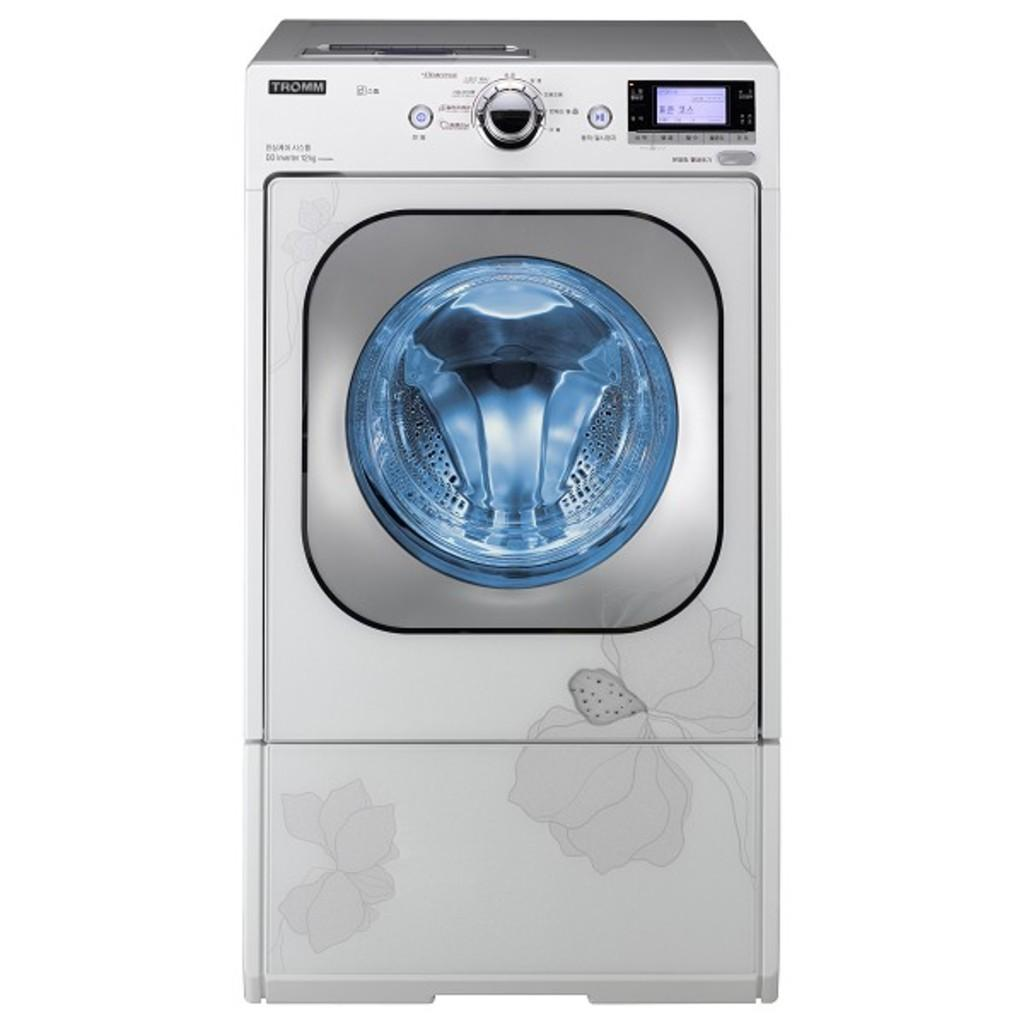What appliance is the main subject of the image? There is a washing machine in the image. Where is the washing machine located in the image? The washing machine is in the center of the image. What word is written on the dress in the image? There is no dress present in the image; it features a washing machine. On what type of surface is the washing machine placed in the image? The provided facts do not mention a surface or table, so we cannot determine where the washing machine is placed in the image. 